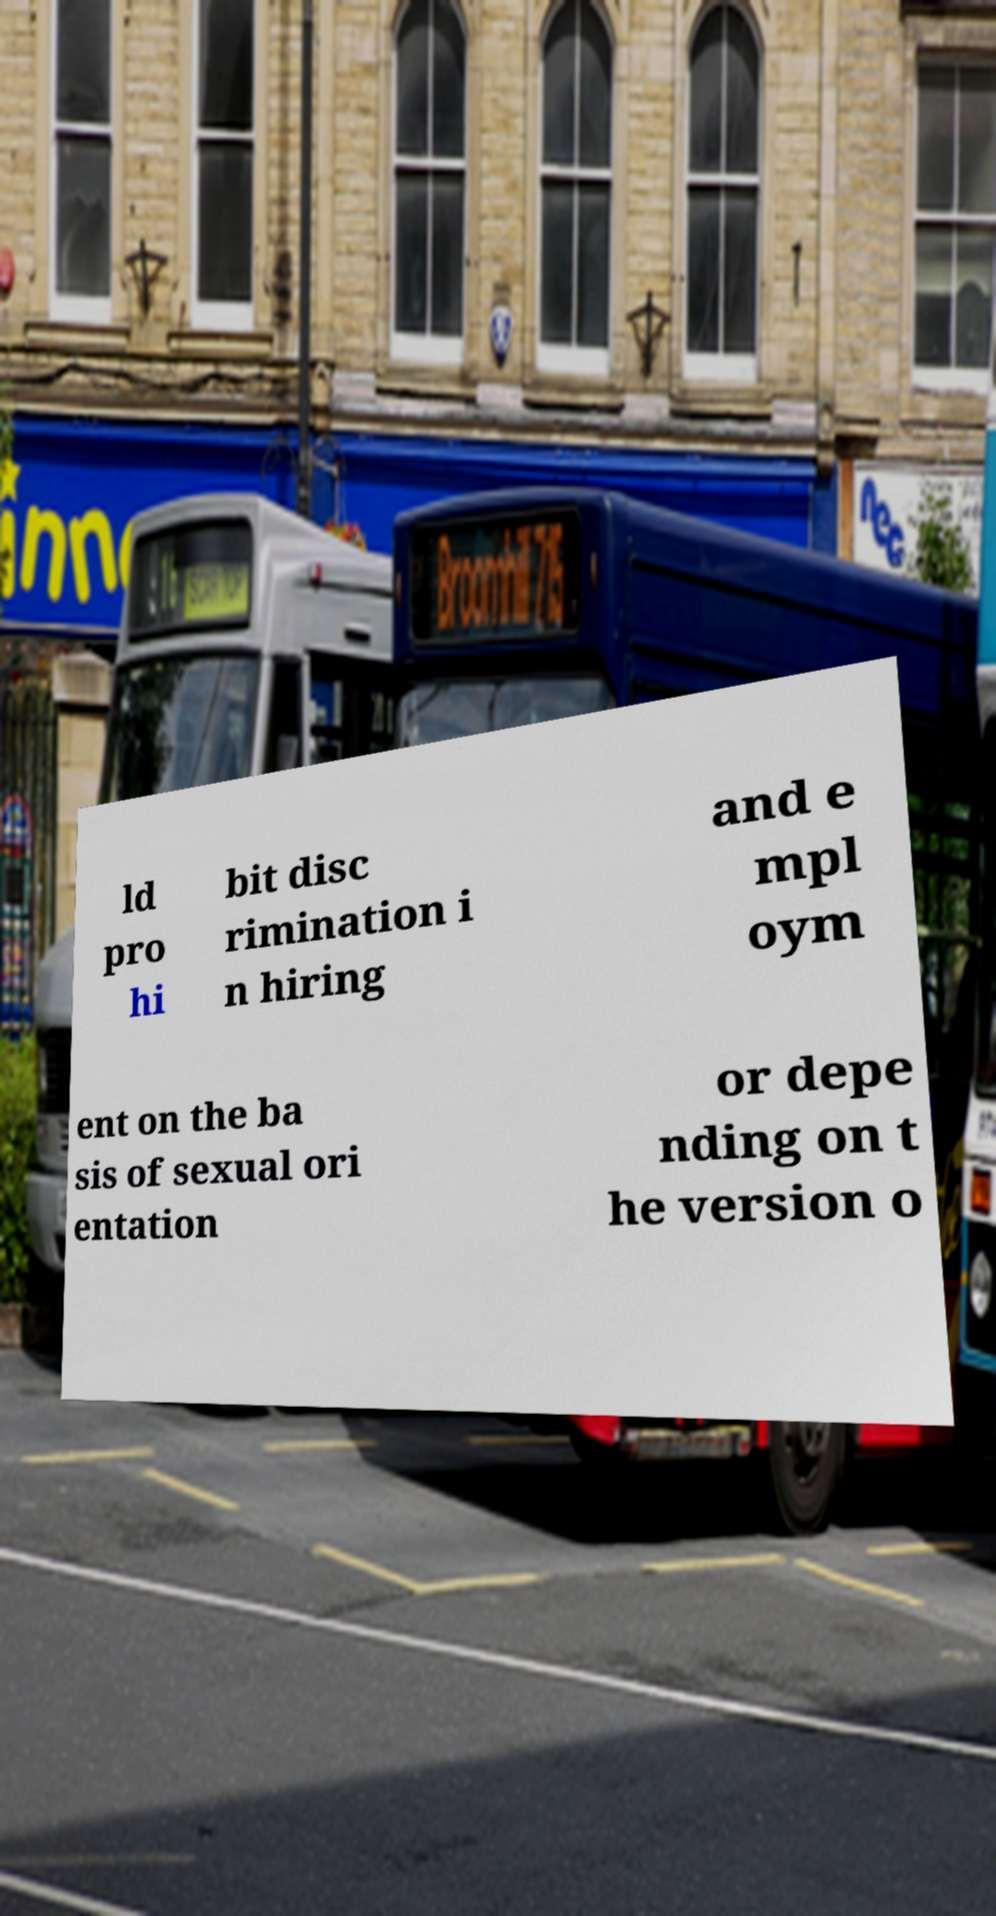Could you assist in decoding the text presented in this image and type it out clearly? ld pro hi bit disc rimination i n hiring and e mpl oym ent on the ba sis of sexual ori entation or depe nding on t he version o 